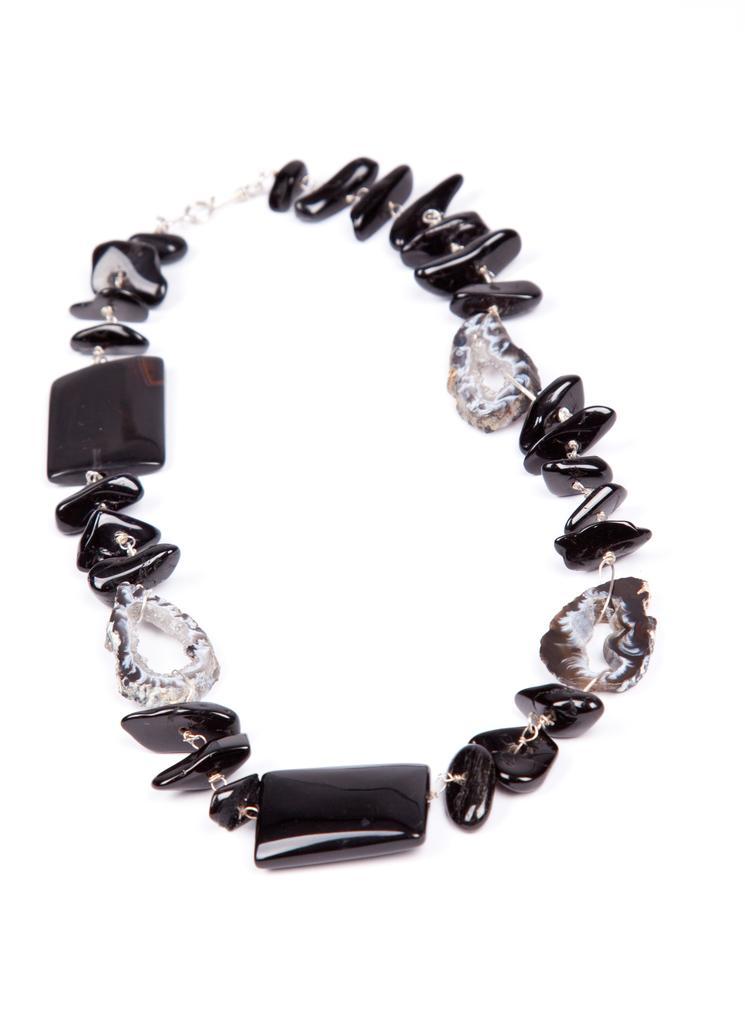Can you describe this image briefly? In this image there is a bracelet with a few black stones and a chain. 